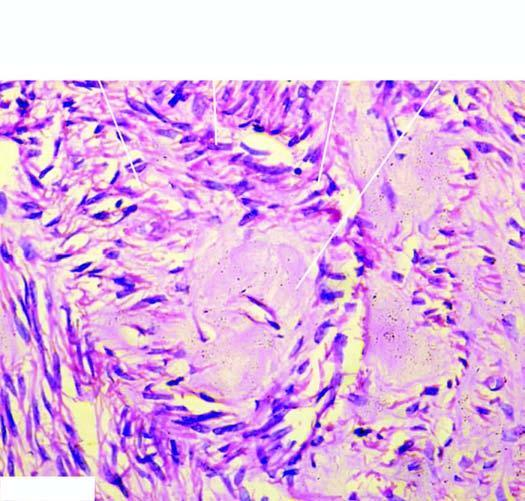do two daughter cells show pink homogeneous hyaline material connective tissue hyaline?
Answer the question using a single word or phrase. No 